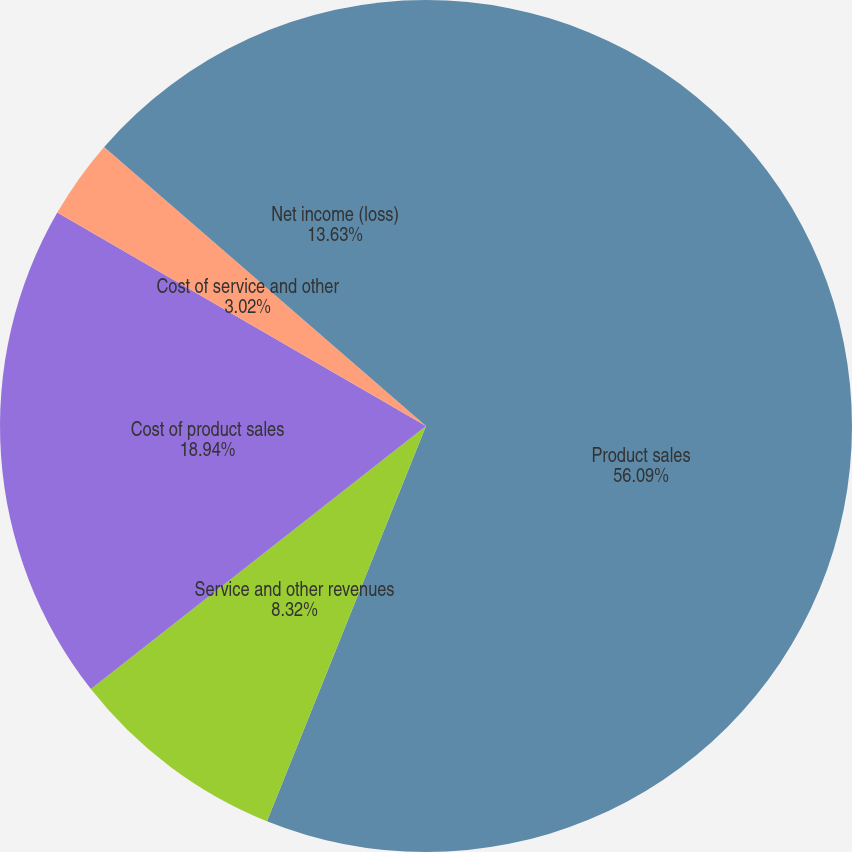Convert chart. <chart><loc_0><loc_0><loc_500><loc_500><pie_chart><fcel>Product sales<fcel>Service and other revenues<fcel>Cost of product sales<fcel>Cost of service and other<fcel>Net income (loss)<nl><fcel>56.09%<fcel>8.32%<fcel>18.94%<fcel>3.02%<fcel>13.63%<nl></chart> 